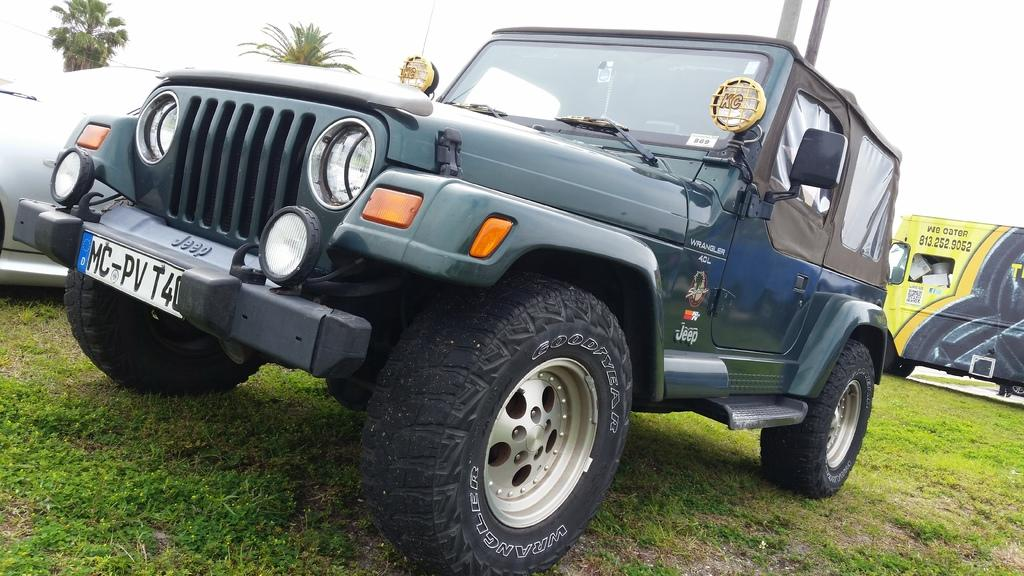What is located on the grass in the center of the image? There are vehicles on the grass in the center of the image. What can be seen in the background of the image? There are trees in the background of the image. What is visible above the trees in the image? There is sky visible in the image. What type of vehicle is present in the image? There is a van in the image. How many cherries are hanging from the trees in the image? There are no cherries visible in the image; only trees are present in the background. What reward is being given to the person driving the van in the image? There is no reward being given in the image; it only shows vehicles on the grass and trees in the background. 